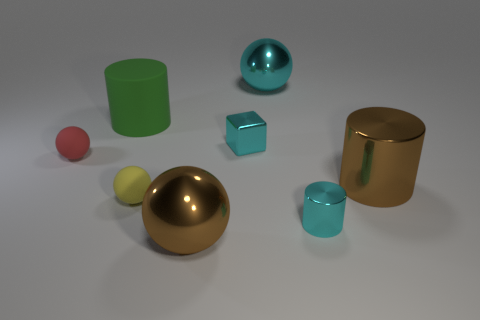There is a large object that is the same color as the tiny block; what is its shape?
Make the answer very short. Sphere. What color is the other large shiny object that is the same shape as the green object?
Provide a short and direct response. Brown. What number of big spheres are the same color as the small cube?
Give a very brief answer. 1. How big is the brown shiny sphere?
Provide a succinct answer. Large. Is the red object the same size as the green cylinder?
Provide a succinct answer. No. What color is the thing that is to the left of the tiny yellow thing and on the right side of the tiny red thing?
Your response must be concise. Green. How many small cyan cylinders have the same material as the big green cylinder?
Ensure brevity in your answer.  0. What number of small objects are there?
Provide a short and direct response. 4. Do the red rubber object and the cyan object that is in front of the large brown metallic cylinder have the same size?
Offer a very short reply. Yes. There is a big sphere that is behind the big brown object that is on the left side of the tiny block; what is it made of?
Give a very brief answer. Metal. 